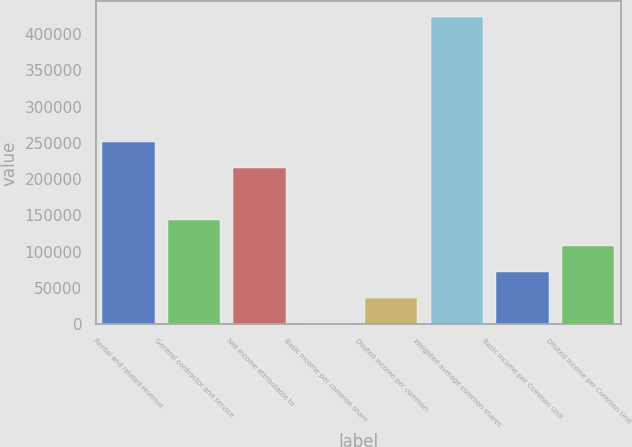Convert chart. <chart><loc_0><loc_0><loc_500><loc_500><bar_chart><fcel>Rental and related revenue<fcel>General contractor and service<fcel>Net income attributable to<fcel>Basic income per common share<fcel>Diluted income per common<fcel>Weighted average common shares<fcel>Basic income per Common Unit<fcel>Diluted income per Common Unit<nl><fcel>251287<fcel>143593<fcel>215389<fcel>0.32<fcel>35898.4<fcel>423652<fcel>71796.5<fcel>107695<nl></chart> 